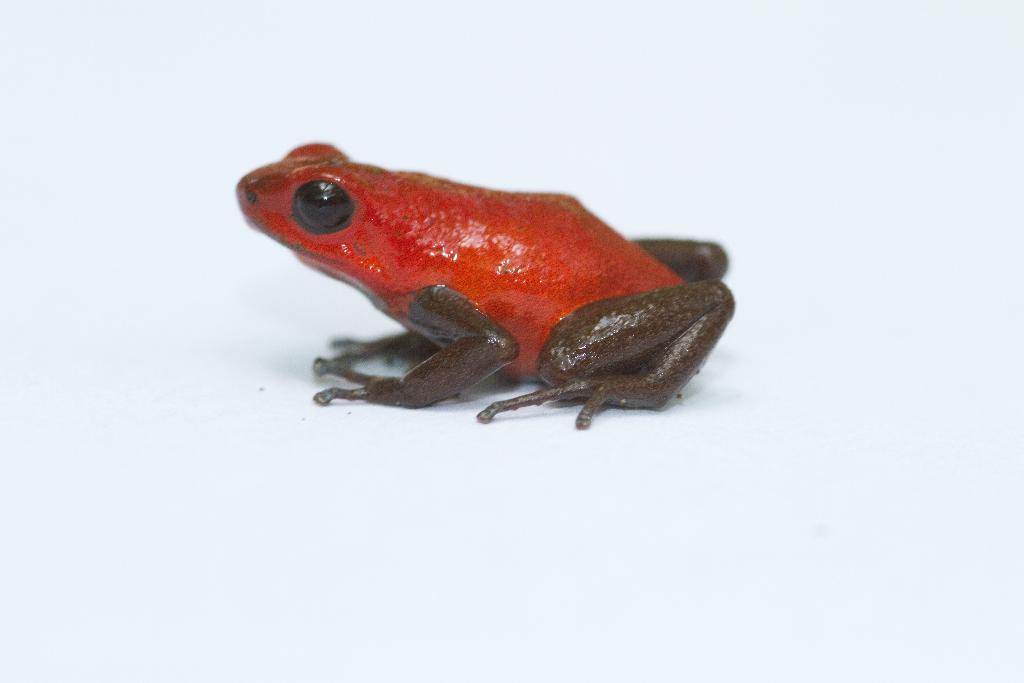What animal is present in the image? There is a frog in the image. What is the color of the surface the frog is on? The frog is on a white surface. Can you see a plane flying over the frog in the image? There is no plane present in the image; it only features a frog on a white surface. 